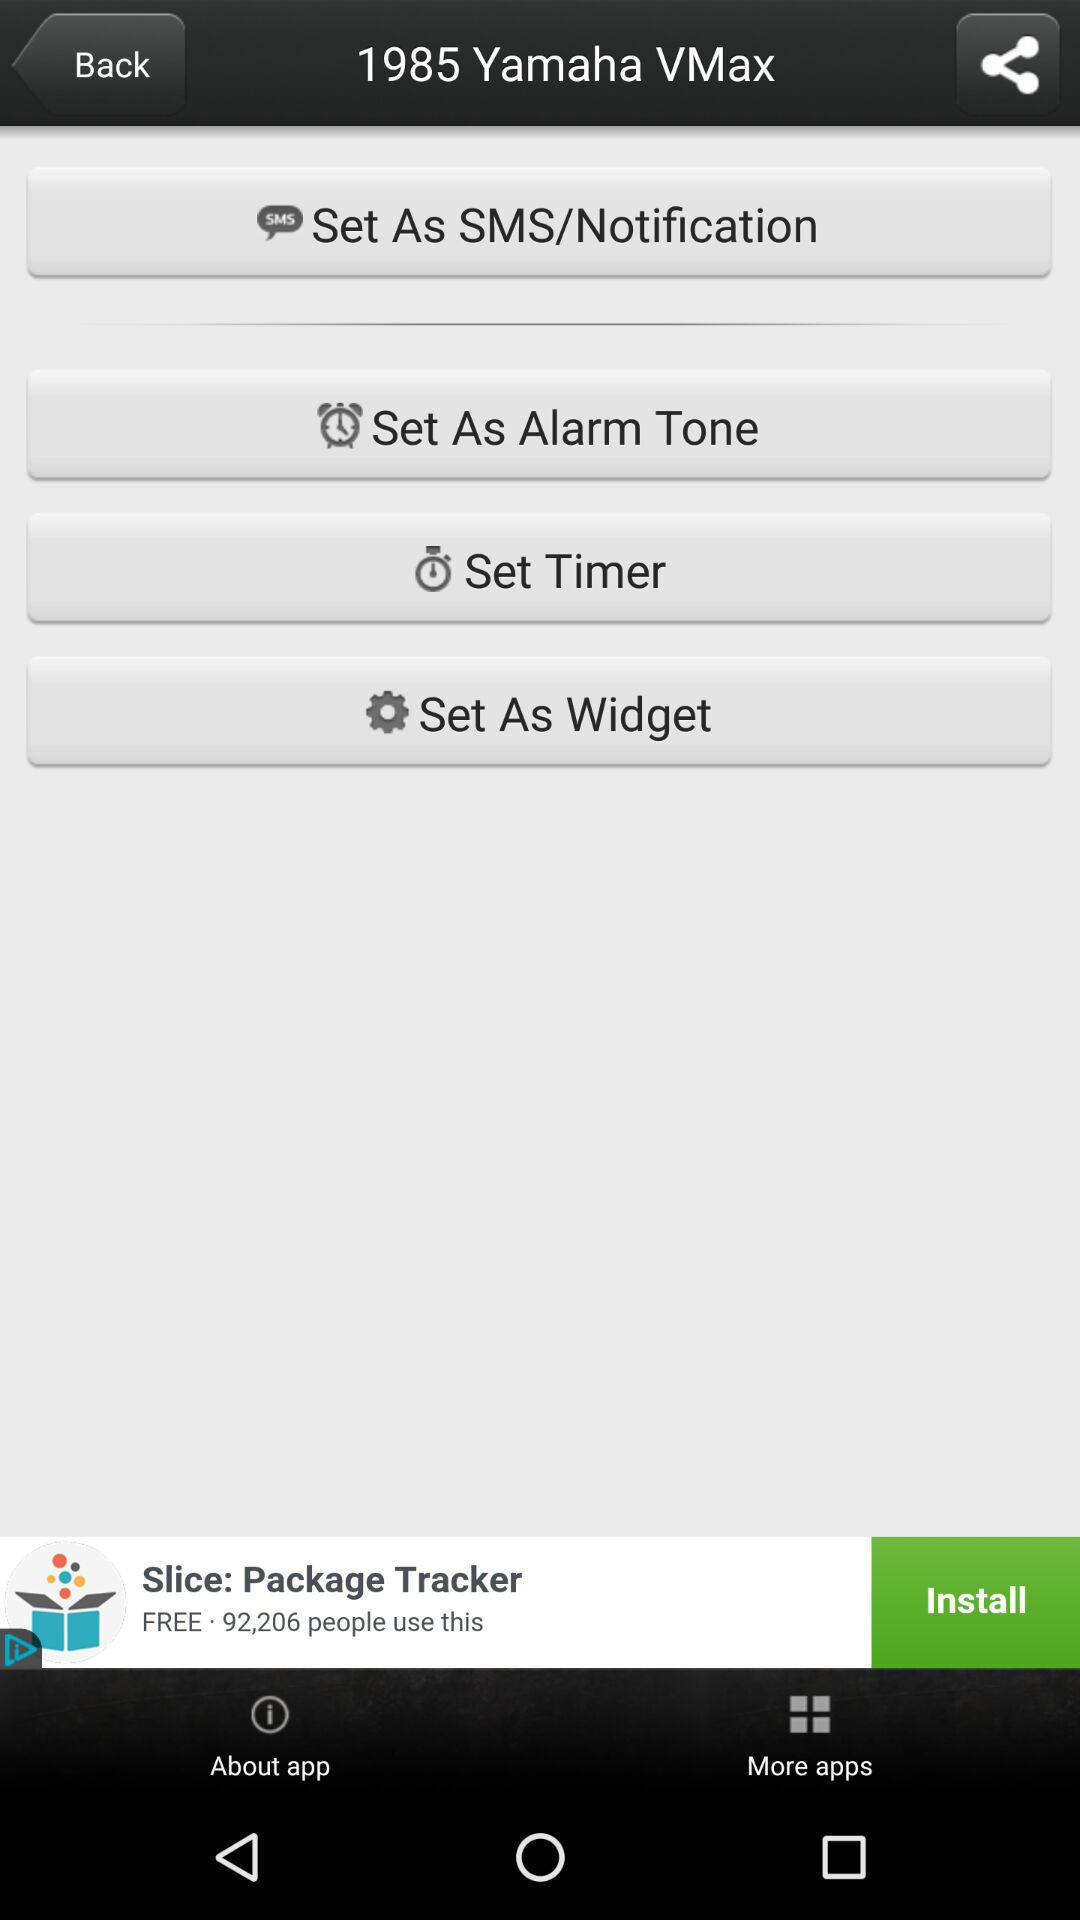What is the version of this application?
When the provided information is insufficient, respond with <no answer>. <no answer> 